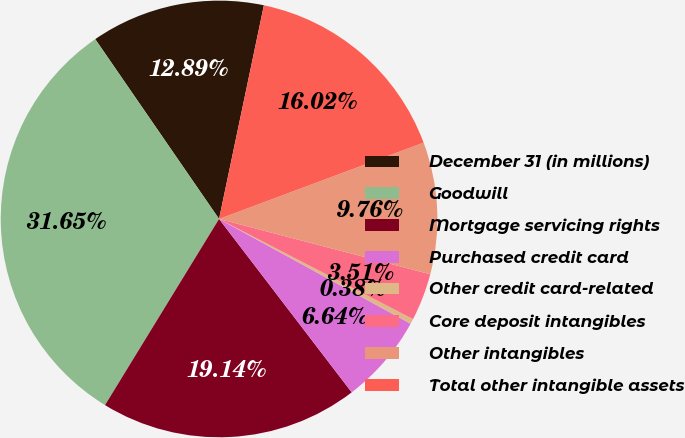Convert chart. <chart><loc_0><loc_0><loc_500><loc_500><pie_chart><fcel>December 31 (in millions)<fcel>Goodwill<fcel>Mortgage servicing rights<fcel>Purchased credit card<fcel>Other credit card-related<fcel>Core deposit intangibles<fcel>Other intangibles<fcel>Total other intangible assets<nl><fcel>12.89%<fcel>31.65%<fcel>19.14%<fcel>6.64%<fcel>0.38%<fcel>3.51%<fcel>9.76%<fcel>16.02%<nl></chart> 